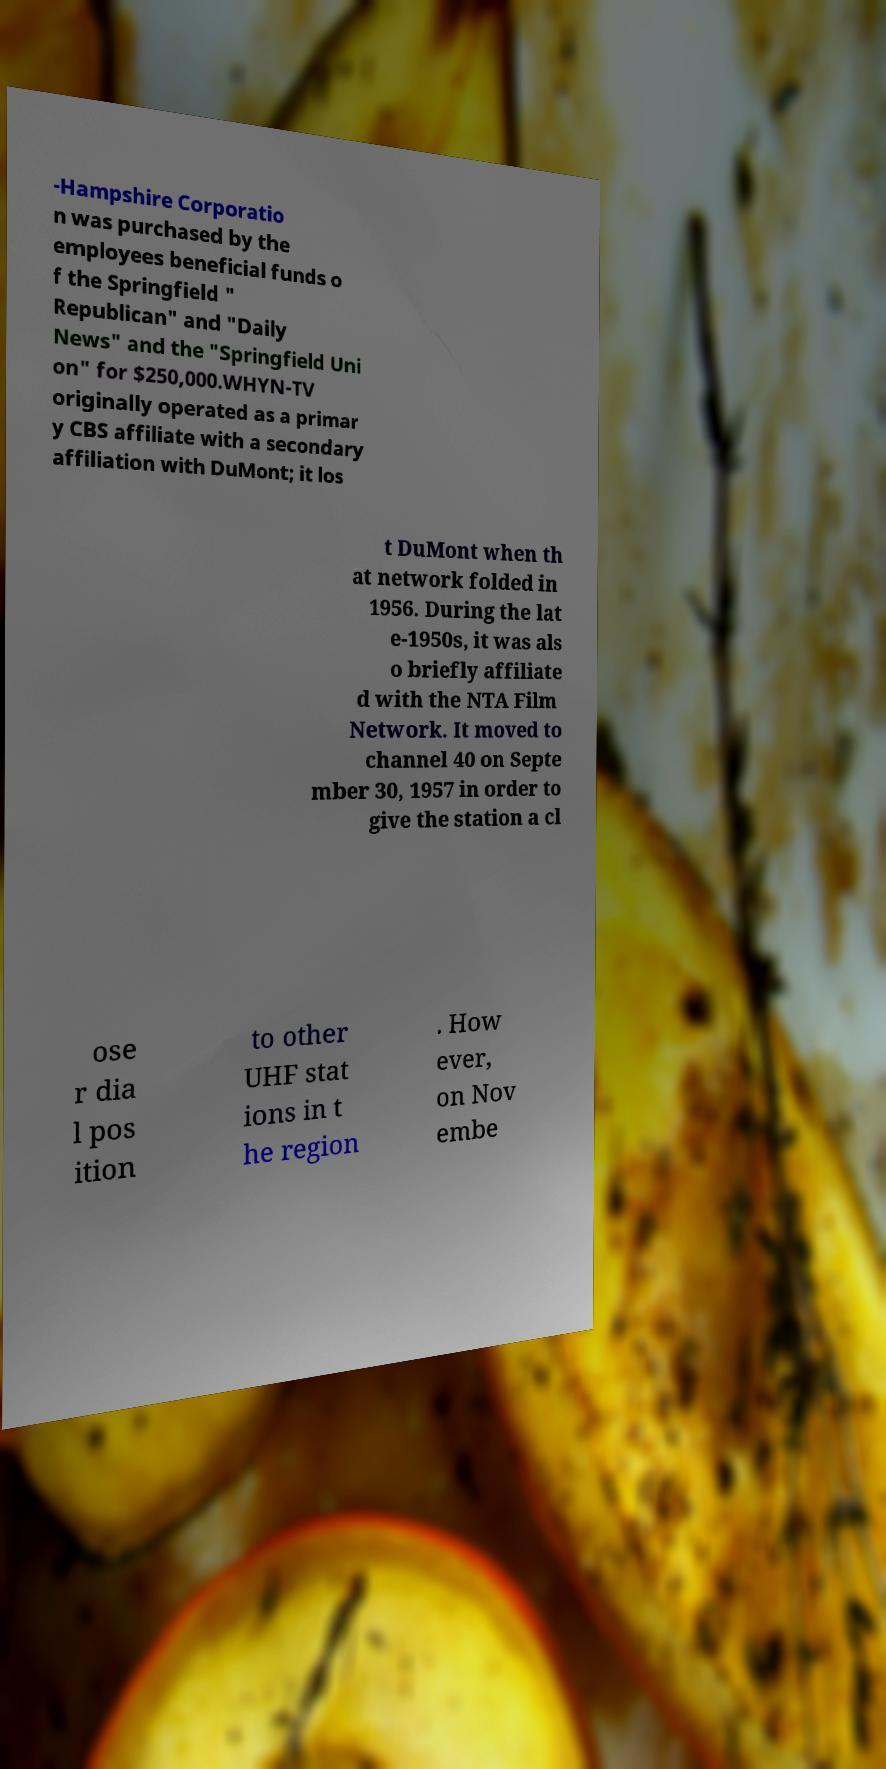Could you extract and type out the text from this image? -Hampshire Corporatio n was purchased by the employees beneficial funds o f the Springfield " Republican" and "Daily News" and the "Springfield Uni on" for $250,000.WHYN-TV originally operated as a primar y CBS affiliate with a secondary affiliation with DuMont; it los t DuMont when th at network folded in 1956. During the lat e-1950s, it was als o briefly affiliate d with the NTA Film Network. It moved to channel 40 on Septe mber 30, 1957 in order to give the station a cl ose r dia l pos ition to other UHF stat ions in t he region . How ever, on Nov embe 